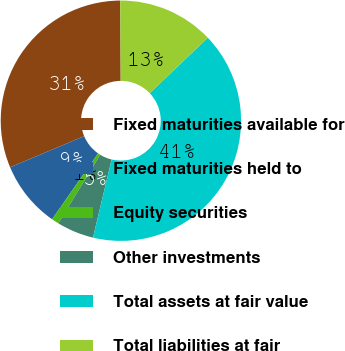Convert chart to OTSL. <chart><loc_0><loc_0><loc_500><loc_500><pie_chart><fcel>Fixed maturities available for<fcel>Fixed maturities held to<fcel>Equity securities<fcel>Other investments<fcel>Total assets at fair value<fcel>Total liabilities at fair<nl><fcel>31.25%<fcel>8.97%<fcel>0.99%<fcel>4.98%<fcel>40.86%<fcel>12.95%<nl></chart> 